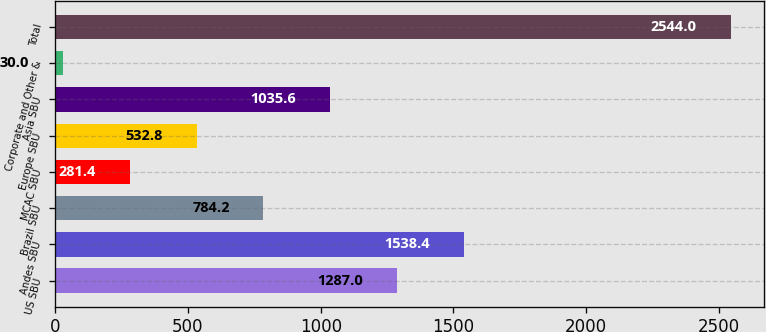<chart> <loc_0><loc_0><loc_500><loc_500><bar_chart><fcel>US SBU<fcel>Andes SBU<fcel>Brazil SBU<fcel>MCAC SBU<fcel>Europe SBU<fcel>Asia SBU<fcel>Corporate and Other &<fcel>Total<nl><fcel>1287<fcel>1538.4<fcel>784.2<fcel>281.4<fcel>532.8<fcel>1035.6<fcel>30<fcel>2544<nl></chart> 